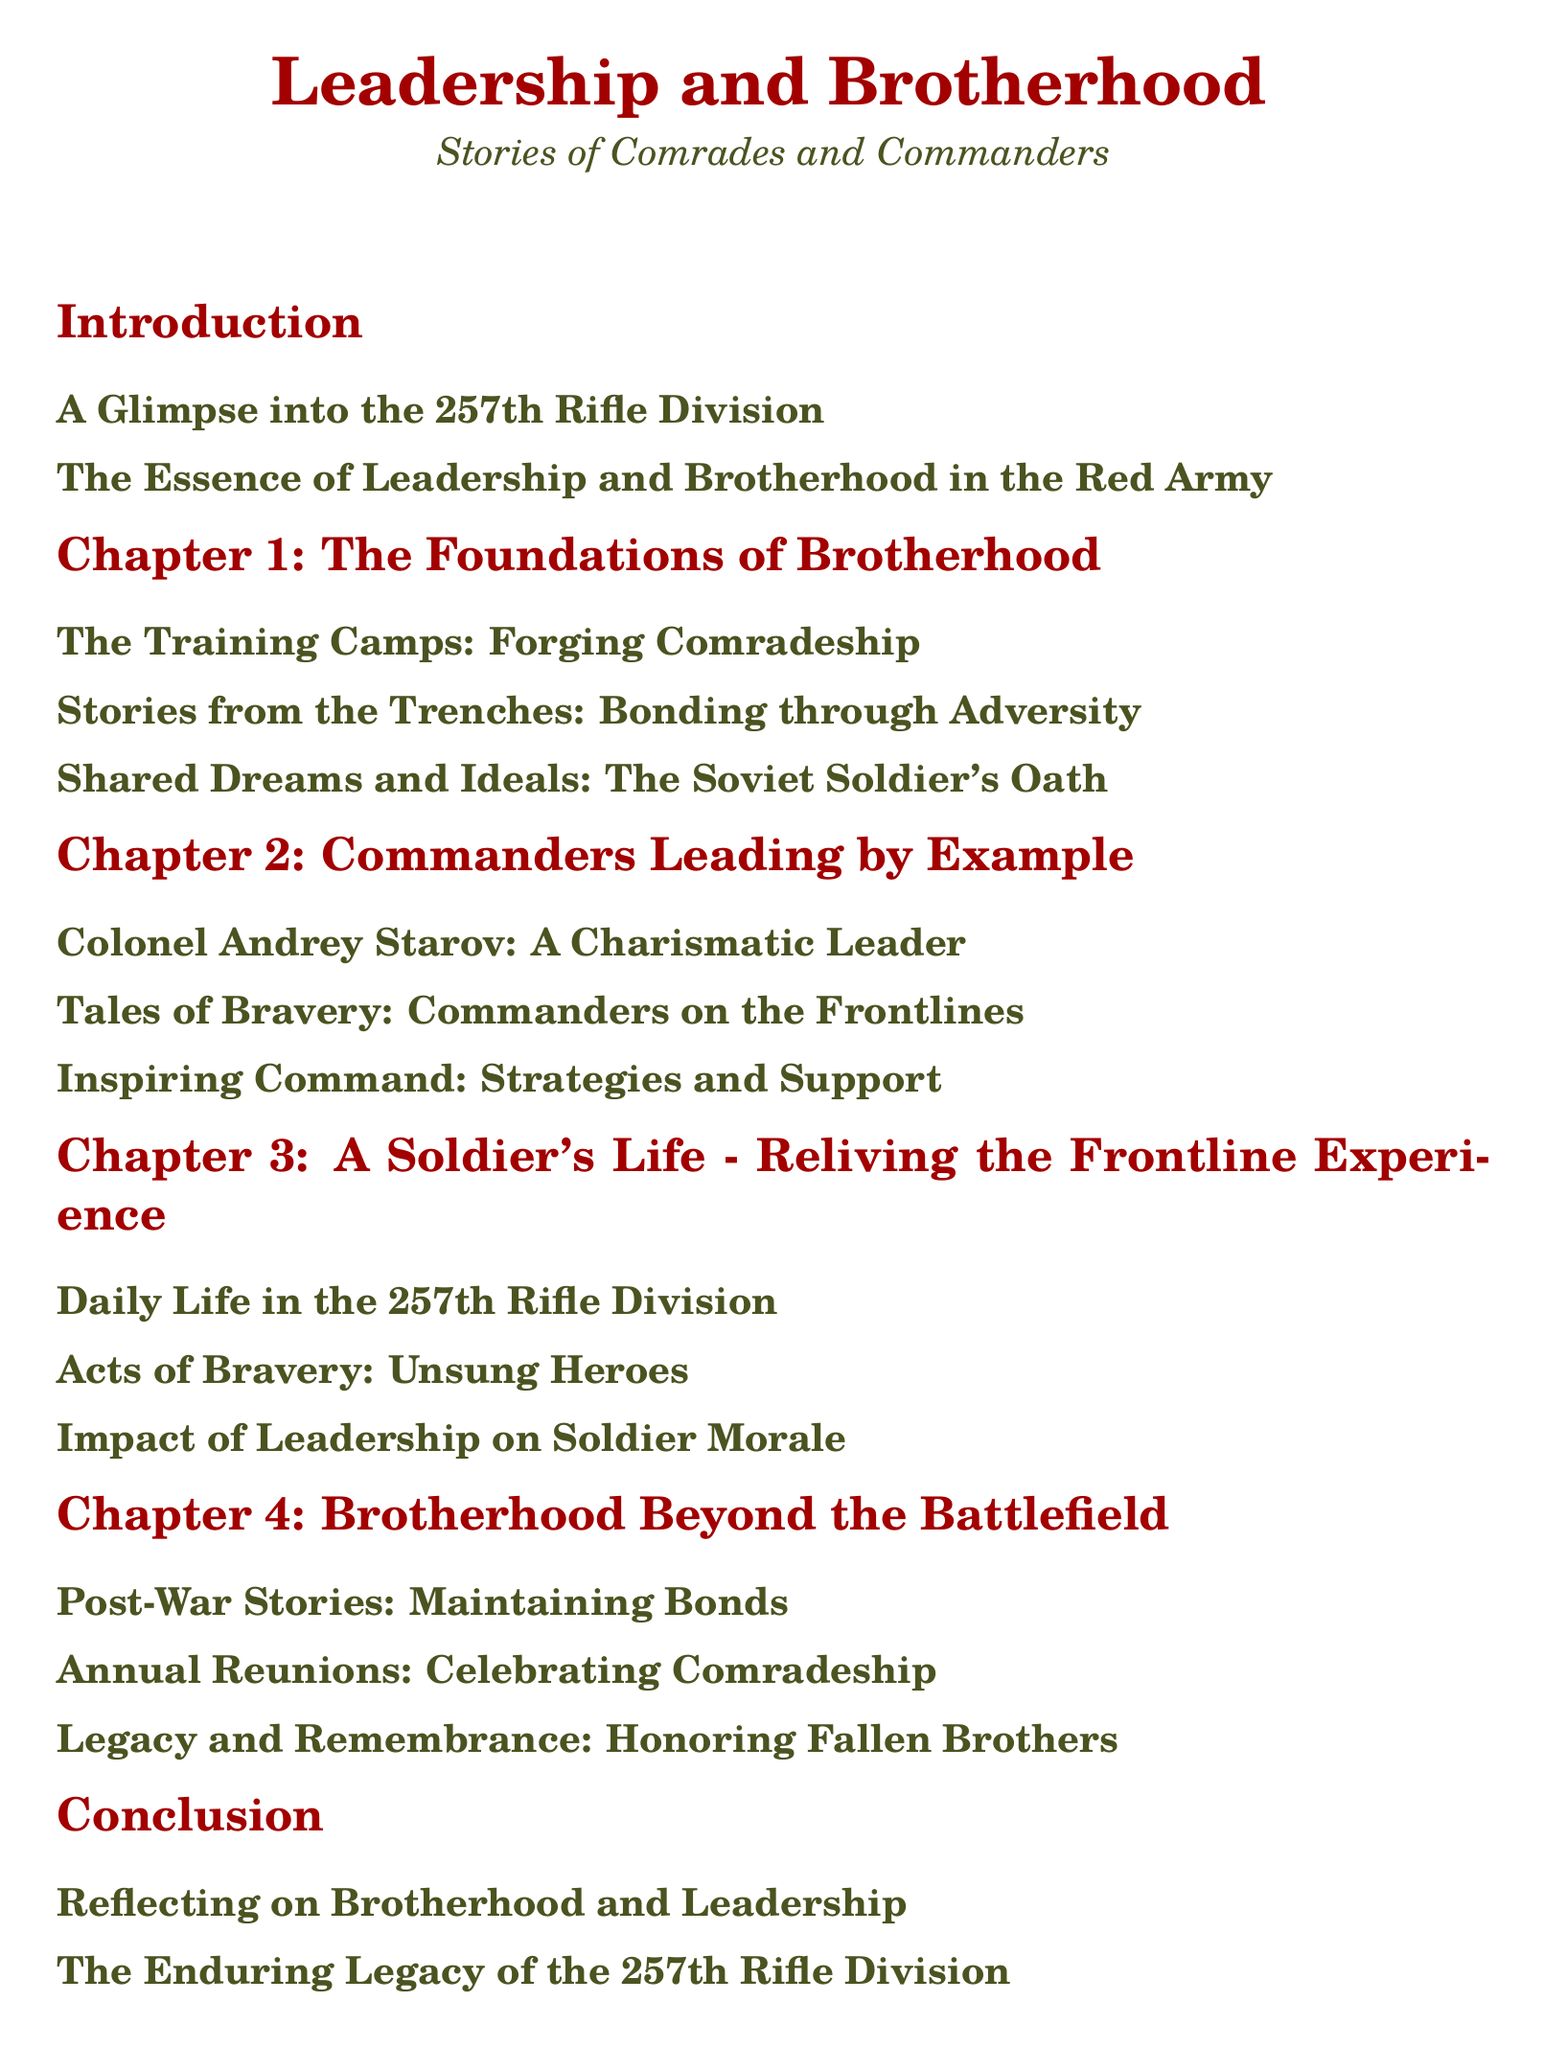What is the title of the document? The document's title is presented at the top as a main heading in the center.
Answer: Leadership and Brotherhood Who is the charismatic leader mentioned in Chapter 2? Chapter 2 lists a specific commander known for his charisma.
Answer: Colonel Andrey Starov What is the focus of Chapter 4? The chapter outlines themes related to relationships and experiences beyond warfare.
Answer: Brotherhood Beyond the Battlefield How many main sections are in the document? By counting the primary sections listed in the Table of Contents, we find the total.
Answer: 6 What does the soldier's oath in Chapter 1 signify? Chapter 1 discusses shared beliefs and commitments of Soviet soldiers.
Answer: Shared Dreams and Ideals In which section can we find post-war stories? The relevant section is specifically aimed at recounting experiences after the war.
Answer: Chapter 4: Brotherhood Beyond the Battlefield What color is associated with the title of the document? The title color is specified in the formatting and style setup at the beginning of the document.
Answer: Soviet Red Which chapter discusses the impact of leadership on soldier morale? The impacts of leadership as discussed within the context of soldier experiences.
Answer: Chapter 3: A Soldier's Life - Reliving the Frontline Experience 